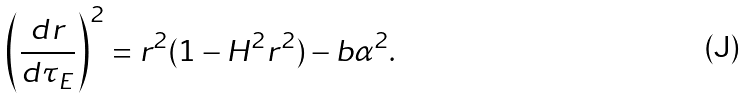Convert formula to latex. <formula><loc_0><loc_0><loc_500><loc_500>\left ( \frac { d r } { d \tau _ { E } } \right ) ^ { 2 } = r ^ { 2 } ( 1 - H ^ { 2 } r ^ { 2 } ) - b \alpha ^ { 2 } .</formula> 